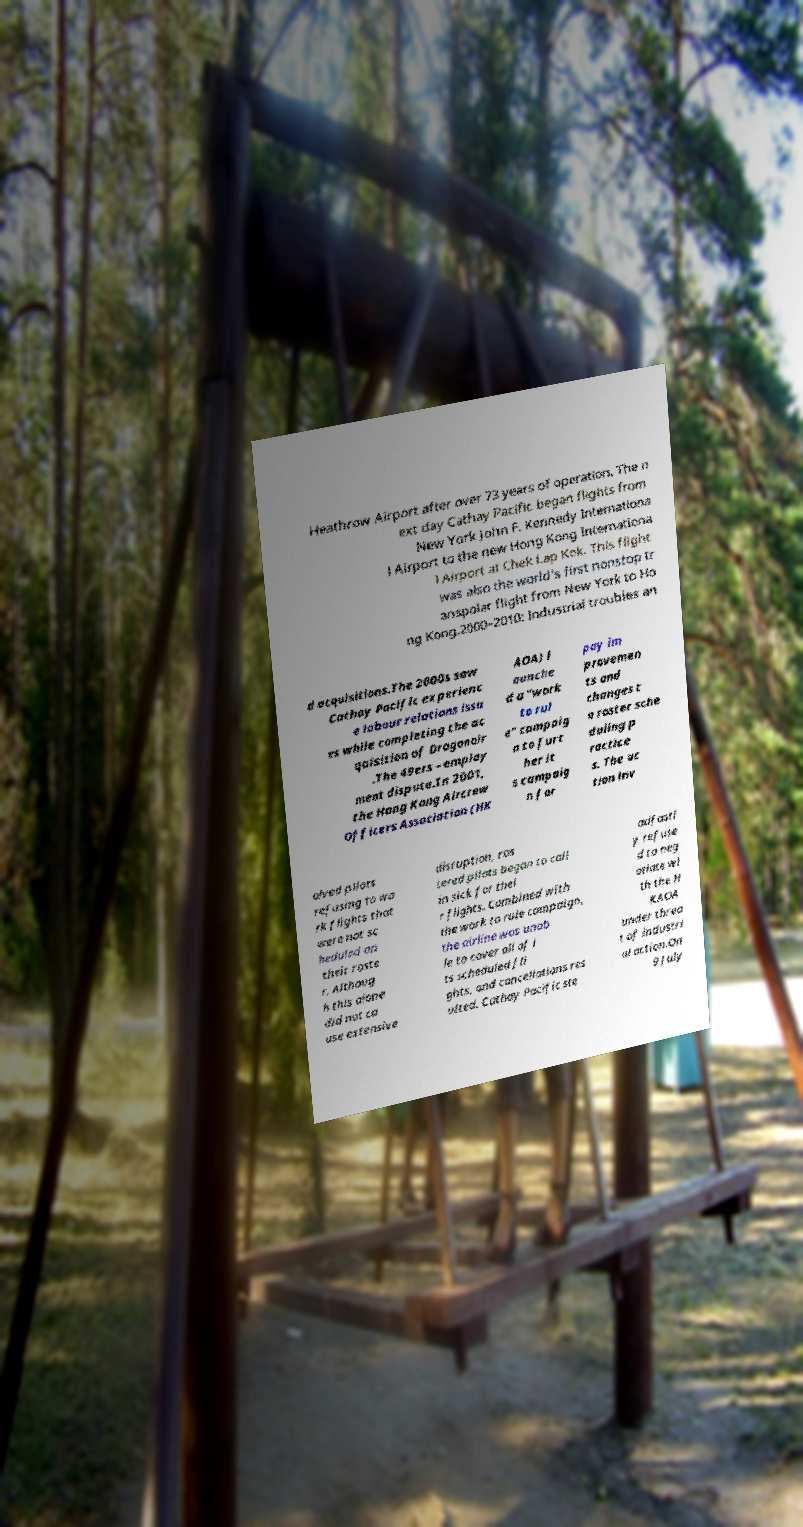I need the written content from this picture converted into text. Can you do that? Heathrow Airport after over 73 years of operation. The n ext day Cathay Pacific began flights from New York John F. Kennedy Internationa l Airport to the new Hong Kong Internationa l Airport at Chek Lap Kok. This flight was also the world's first nonstop tr anspolar flight from New York to Ho ng Kong.2000–2010: Industrial troubles an d acquisitions.The 2000s saw Cathay Pacific experienc e labour relations issu es while completing the ac quisition of Dragonair .The 49ers – employ ment dispute.In 2001, the Hong Kong Aircrew Officers Association (HK AOA) l aunche d a "work to rul e" campaig n to furt her it s campaig n for pay im provemen ts and changes t o roster sche duling p ractice s. The ac tion inv olved pilots refusing to wo rk flights that were not sc heduled on their roste r. Althoug h this alone did not ca use extensive disruption, ros tered pilots began to call in sick for thei r flights. Combined with the work to rule campaign, the airline was unab le to cover all of i ts scheduled fli ghts, and cancellations res ulted. Cathay Pacific ste adfastl y refuse d to neg otiate wi th the H KAOA under threa t of industri al action.On 9 July 